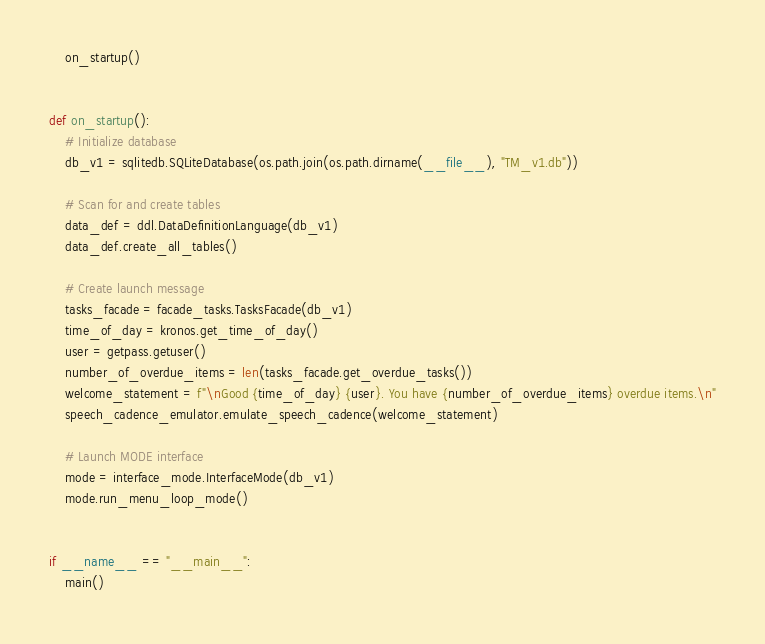Convert code to text. <code><loc_0><loc_0><loc_500><loc_500><_Python_>    on_startup()


def on_startup():
    # Initialize database
    db_v1 = sqlitedb.SQLiteDatabase(os.path.join(os.path.dirname(__file__), "TM_v1.db"))

    # Scan for and create tables
    data_def = ddl.DataDefinitionLanguage(db_v1)
    data_def.create_all_tables()

    # Create launch message
    tasks_facade = facade_tasks.TasksFacade(db_v1)
    time_of_day = kronos.get_time_of_day()
    user = getpass.getuser()
    number_of_overdue_items = len(tasks_facade.get_overdue_tasks())
    welcome_statement = f"\nGood {time_of_day} {user}. You have {number_of_overdue_items} overdue items.\n"
    speech_cadence_emulator.emulate_speech_cadence(welcome_statement)

    # Launch MODE interface
    mode = interface_mode.InterfaceMode(db_v1)
    mode.run_menu_loop_mode()


if __name__ == "__main__":
    main()
</code> 